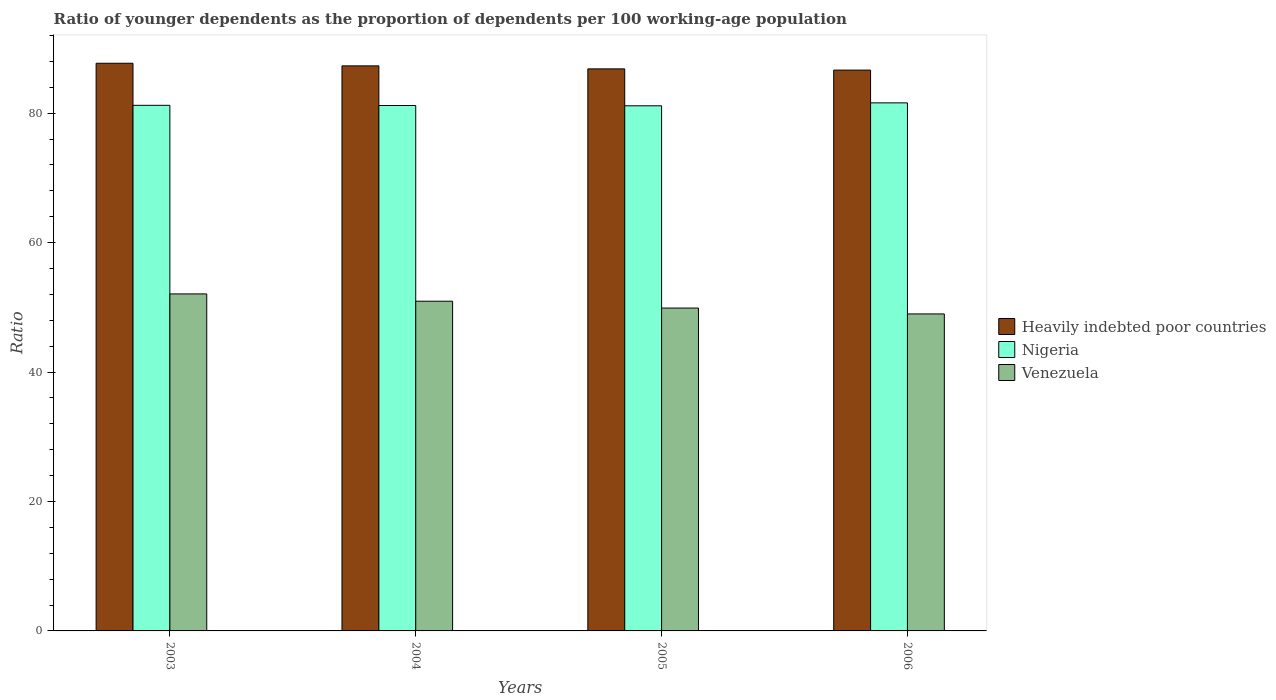How many different coloured bars are there?
Give a very brief answer. 3. Are the number of bars per tick equal to the number of legend labels?
Offer a very short reply. Yes. In how many cases, is the number of bars for a given year not equal to the number of legend labels?
Provide a succinct answer. 0. What is the age dependency ratio(young) in Venezuela in 2004?
Your answer should be very brief. 50.95. Across all years, what is the maximum age dependency ratio(young) in Venezuela?
Your answer should be very brief. 52.08. Across all years, what is the minimum age dependency ratio(young) in Nigeria?
Your answer should be compact. 81.14. In which year was the age dependency ratio(young) in Nigeria maximum?
Your answer should be very brief. 2006. What is the total age dependency ratio(young) in Nigeria in the graph?
Provide a short and direct response. 325.15. What is the difference between the age dependency ratio(young) in Heavily indebted poor countries in 2003 and that in 2006?
Provide a short and direct response. 1.06. What is the difference between the age dependency ratio(young) in Venezuela in 2003 and the age dependency ratio(young) in Nigeria in 2004?
Keep it short and to the point. -29.11. What is the average age dependency ratio(young) in Heavily indebted poor countries per year?
Offer a very short reply. 87.13. In the year 2005, what is the difference between the age dependency ratio(young) in Nigeria and age dependency ratio(young) in Venezuela?
Your answer should be very brief. 31.25. In how many years, is the age dependency ratio(young) in Heavily indebted poor countries greater than 64?
Offer a terse response. 4. What is the ratio of the age dependency ratio(young) in Heavily indebted poor countries in 2003 to that in 2004?
Your answer should be compact. 1. What is the difference between the highest and the second highest age dependency ratio(young) in Nigeria?
Make the answer very short. 0.38. What is the difference between the highest and the lowest age dependency ratio(young) in Nigeria?
Provide a succinct answer. 0.45. What does the 3rd bar from the left in 2005 represents?
Your response must be concise. Venezuela. What does the 1st bar from the right in 2004 represents?
Provide a succinct answer. Venezuela. Are all the bars in the graph horizontal?
Offer a terse response. No. Does the graph contain grids?
Your answer should be compact. No. How many legend labels are there?
Provide a short and direct response. 3. What is the title of the graph?
Keep it short and to the point. Ratio of younger dependents as the proportion of dependents per 100 working-age population. What is the label or title of the Y-axis?
Your response must be concise. Ratio. What is the Ratio in Heavily indebted poor countries in 2003?
Provide a short and direct response. 87.72. What is the Ratio of Nigeria in 2003?
Your answer should be compact. 81.22. What is the Ratio of Venezuela in 2003?
Your answer should be compact. 52.08. What is the Ratio in Heavily indebted poor countries in 2004?
Provide a succinct answer. 87.31. What is the Ratio of Nigeria in 2004?
Your answer should be compact. 81.19. What is the Ratio of Venezuela in 2004?
Your answer should be compact. 50.95. What is the Ratio of Heavily indebted poor countries in 2005?
Offer a terse response. 86.85. What is the Ratio in Nigeria in 2005?
Keep it short and to the point. 81.14. What is the Ratio of Venezuela in 2005?
Offer a very short reply. 49.89. What is the Ratio in Heavily indebted poor countries in 2006?
Your response must be concise. 86.66. What is the Ratio of Nigeria in 2006?
Your answer should be compact. 81.6. What is the Ratio in Venezuela in 2006?
Keep it short and to the point. 48.98. Across all years, what is the maximum Ratio of Heavily indebted poor countries?
Your answer should be very brief. 87.72. Across all years, what is the maximum Ratio in Nigeria?
Provide a short and direct response. 81.6. Across all years, what is the maximum Ratio of Venezuela?
Make the answer very short. 52.08. Across all years, what is the minimum Ratio in Heavily indebted poor countries?
Your response must be concise. 86.66. Across all years, what is the minimum Ratio of Nigeria?
Your answer should be compact. 81.14. Across all years, what is the minimum Ratio in Venezuela?
Make the answer very short. 48.98. What is the total Ratio in Heavily indebted poor countries in the graph?
Offer a very short reply. 348.54. What is the total Ratio of Nigeria in the graph?
Offer a terse response. 325.15. What is the total Ratio in Venezuela in the graph?
Provide a succinct answer. 201.9. What is the difference between the Ratio of Heavily indebted poor countries in 2003 and that in 2004?
Your answer should be very brief. 0.4. What is the difference between the Ratio of Nigeria in 2003 and that in 2004?
Give a very brief answer. 0.03. What is the difference between the Ratio in Venezuela in 2003 and that in 2004?
Give a very brief answer. 1.13. What is the difference between the Ratio of Heavily indebted poor countries in 2003 and that in 2005?
Keep it short and to the point. 0.87. What is the difference between the Ratio in Nigeria in 2003 and that in 2005?
Your response must be concise. 0.07. What is the difference between the Ratio of Venezuela in 2003 and that in 2005?
Make the answer very short. 2.19. What is the difference between the Ratio in Heavily indebted poor countries in 2003 and that in 2006?
Keep it short and to the point. 1.06. What is the difference between the Ratio of Nigeria in 2003 and that in 2006?
Your answer should be very brief. -0.38. What is the difference between the Ratio of Venezuela in 2003 and that in 2006?
Your response must be concise. 3.09. What is the difference between the Ratio in Heavily indebted poor countries in 2004 and that in 2005?
Provide a short and direct response. 0.46. What is the difference between the Ratio in Nigeria in 2004 and that in 2005?
Keep it short and to the point. 0.04. What is the difference between the Ratio in Venezuela in 2004 and that in 2005?
Your answer should be compact. 1.06. What is the difference between the Ratio in Heavily indebted poor countries in 2004 and that in 2006?
Provide a short and direct response. 0.65. What is the difference between the Ratio of Nigeria in 2004 and that in 2006?
Your answer should be very brief. -0.41. What is the difference between the Ratio of Venezuela in 2004 and that in 2006?
Your response must be concise. 1.97. What is the difference between the Ratio in Heavily indebted poor countries in 2005 and that in 2006?
Your answer should be very brief. 0.19. What is the difference between the Ratio of Nigeria in 2005 and that in 2006?
Offer a terse response. -0.45. What is the difference between the Ratio of Venezuela in 2005 and that in 2006?
Your response must be concise. 0.91. What is the difference between the Ratio of Heavily indebted poor countries in 2003 and the Ratio of Nigeria in 2004?
Offer a very short reply. 6.53. What is the difference between the Ratio of Heavily indebted poor countries in 2003 and the Ratio of Venezuela in 2004?
Ensure brevity in your answer.  36.77. What is the difference between the Ratio in Nigeria in 2003 and the Ratio in Venezuela in 2004?
Keep it short and to the point. 30.27. What is the difference between the Ratio in Heavily indebted poor countries in 2003 and the Ratio in Nigeria in 2005?
Provide a succinct answer. 6.57. What is the difference between the Ratio of Heavily indebted poor countries in 2003 and the Ratio of Venezuela in 2005?
Provide a short and direct response. 37.83. What is the difference between the Ratio in Nigeria in 2003 and the Ratio in Venezuela in 2005?
Ensure brevity in your answer.  31.33. What is the difference between the Ratio of Heavily indebted poor countries in 2003 and the Ratio of Nigeria in 2006?
Make the answer very short. 6.12. What is the difference between the Ratio in Heavily indebted poor countries in 2003 and the Ratio in Venezuela in 2006?
Offer a terse response. 38.74. What is the difference between the Ratio of Nigeria in 2003 and the Ratio of Venezuela in 2006?
Your answer should be very brief. 32.24. What is the difference between the Ratio in Heavily indebted poor countries in 2004 and the Ratio in Nigeria in 2005?
Make the answer very short. 6.17. What is the difference between the Ratio in Heavily indebted poor countries in 2004 and the Ratio in Venezuela in 2005?
Your answer should be very brief. 37.42. What is the difference between the Ratio in Nigeria in 2004 and the Ratio in Venezuela in 2005?
Make the answer very short. 31.3. What is the difference between the Ratio of Heavily indebted poor countries in 2004 and the Ratio of Nigeria in 2006?
Offer a terse response. 5.72. What is the difference between the Ratio of Heavily indebted poor countries in 2004 and the Ratio of Venezuela in 2006?
Your response must be concise. 38.33. What is the difference between the Ratio of Nigeria in 2004 and the Ratio of Venezuela in 2006?
Ensure brevity in your answer.  32.21. What is the difference between the Ratio in Heavily indebted poor countries in 2005 and the Ratio in Nigeria in 2006?
Offer a terse response. 5.25. What is the difference between the Ratio in Heavily indebted poor countries in 2005 and the Ratio in Venezuela in 2006?
Your answer should be compact. 37.87. What is the difference between the Ratio of Nigeria in 2005 and the Ratio of Venezuela in 2006?
Make the answer very short. 32.16. What is the average Ratio of Heavily indebted poor countries per year?
Ensure brevity in your answer.  87.13. What is the average Ratio of Nigeria per year?
Ensure brevity in your answer.  81.29. What is the average Ratio in Venezuela per year?
Your response must be concise. 50.47. In the year 2003, what is the difference between the Ratio in Heavily indebted poor countries and Ratio in Nigeria?
Your response must be concise. 6.5. In the year 2003, what is the difference between the Ratio in Heavily indebted poor countries and Ratio in Venezuela?
Ensure brevity in your answer.  35.64. In the year 2003, what is the difference between the Ratio of Nigeria and Ratio of Venezuela?
Ensure brevity in your answer.  29.14. In the year 2004, what is the difference between the Ratio in Heavily indebted poor countries and Ratio in Nigeria?
Your answer should be compact. 6.12. In the year 2004, what is the difference between the Ratio of Heavily indebted poor countries and Ratio of Venezuela?
Your response must be concise. 36.37. In the year 2004, what is the difference between the Ratio in Nigeria and Ratio in Venezuela?
Offer a terse response. 30.24. In the year 2005, what is the difference between the Ratio of Heavily indebted poor countries and Ratio of Nigeria?
Give a very brief answer. 5.7. In the year 2005, what is the difference between the Ratio of Heavily indebted poor countries and Ratio of Venezuela?
Offer a terse response. 36.96. In the year 2005, what is the difference between the Ratio of Nigeria and Ratio of Venezuela?
Keep it short and to the point. 31.25. In the year 2006, what is the difference between the Ratio of Heavily indebted poor countries and Ratio of Nigeria?
Offer a terse response. 5.06. In the year 2006, what is the difference between the Ratio of Heavily indebted poor countries and Ratio of Venezuela?
Provide a succinct answer. 37.68. In the year 2006, what is the difference between the Ratio of Nigeria and Ratio of Venezuela?
Your response must be concise. 32.62. What is the ratio of the Ratio of Venezuela in 2003 to that in 2004?
Give a very brief answer. 1.02. What is the ratio of the Ratio of Venezuela in 2003 to that in 2005?
Provide a succinct answer. 1.04. What is the ratio of the Ratio of Heavily indebted poor countries in 2003 to that in 2006?
Provide a short and direct response. 1.01. What is the ratio of the Ratio of Nigeria in 2003 to that in 2006?
Give a very brief answer. 1. What is the ratio of the Ratio in Venezuela in 2003 to that in 2006?
Make the answer very short. 1.06. What is the ratio of the Ratio in Heavily indebted poor countries in 2004 to that in 2005?
Give a very brief answer. 1.01. What is the ratio of the Ratio in Venezuela in 2004 to that in 2005?
Make the answer very short. 1.02. What is the ratio of the Ratio of Heavily indebted poor countries in 2004 to that in 2006?
Your answer should be very brief. 1.01. What is the ratio of the Ratio of Nigeria in 2004 to that in 2006?
Make the answer very short. 0.99. What is the ratio of the Ratio of Venezuela in 2004 to that in 2006?
Make the answer very short. 1.04. What is the ratio of the Ratio of Venezuela in 2005 to that in 2006?
Offer a very short reply. 1.02. What is the difference between the highest and the second highest Ratio of Heavily indebted poor countries?
Provide a succinct answer. 0.4. What is the difference between the highest and the second highest Ratio of Nigeria?
Make the answer very short. 0.38. What is the difference between the highest and the second highest Ratio in Venezuela?
Ensure brevity in your answer.  1.13. What is the difference between the highest and the lowest Ratio of Heavily indebted poor countries?
Keep it short and to the point. 1.06. What is the difference between the highest and the lowest Ratio of Nigeria?
Give a very brief answer. 0.45. What is the difference between the highest and the lowest Ratio of Venezuela?
Offer a very short reply. 3.09. 